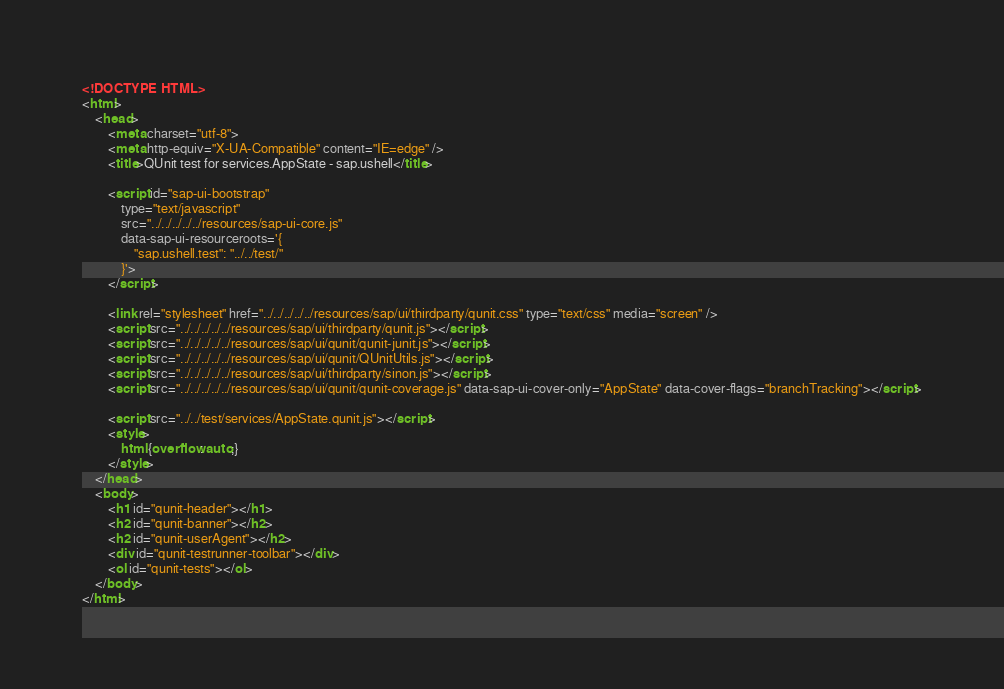<code> <loc_0><loc_0><loc_500><loc_500><_HTML_><!DOCTYPE HTML>
<html>
    <head>
        <meta charset="utf-8">
        <meta http-equiv="X-UA-Compatible" content="IE=edge" />
        <title>QUnit test for services.AppState - sap.ushell</title>

        <script id="sap-ui-bootstrap"
            type="text/javascript"
            src="../../../../../resources/sap-ui-core.js"
            data-sap-ui-resourceroots='{
                "sap.ushell.test": "../../test/"
            }'>
        </script>

        <link rel="stylesheet" href="../../../../../resources/sap/ui/thirdparty/qunit.css" type="text/css" media="screen" />
        <script src="../../../../../resources/sap/ui/thirdparty/qunit.js"></script>
        <script src="../../../../../resources/sap/ui/qunit/qunit-junit.js"></script>
        <script src="../../../../../resources/sap/ui/qunit/QUnitUtils.js"></script>
        <script src="../../../../../resources/sap/ui/thirdparty/sinon.js"></script>
        <script src="../../../../../resources/sap/ui/qunit/qunit-coverage.js" data-sap-ui-cover-only="AppState" data-cover-flags="branchTracking"></script>

        <script src="../../test/services/AppState.qunit.js"></script>
        <style>
            html {overflow: auto;}
        </style>
    </head>
    <body>
        <h1 id="qunit-header"></h1>
        <h2 id="qunit-banner"></h2>
        <h2 id="qunit-userAgent"></h2>
        <div id="qunit-testrunner-toolbar"></div>
        <ol id="qunit-tests"></ol>
    </body>
</html></code> 